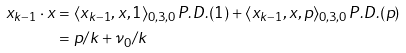Convert formula to latex. <formula><loc_0><loc_0><loc_500><loc_500>x _ { k - 1 } \cdot x & = \langle x _ { k - 1 } , x , 1 \rangle _ { 0 , 3 , 0 } P . D . ( 1 ) + \langle x _ { k - 1 } , x , p \rangle _ { 0 , 3 , 0 } P . D . ( p ) \\ & = p / k + \nu _ { 0 } / k</formula> 